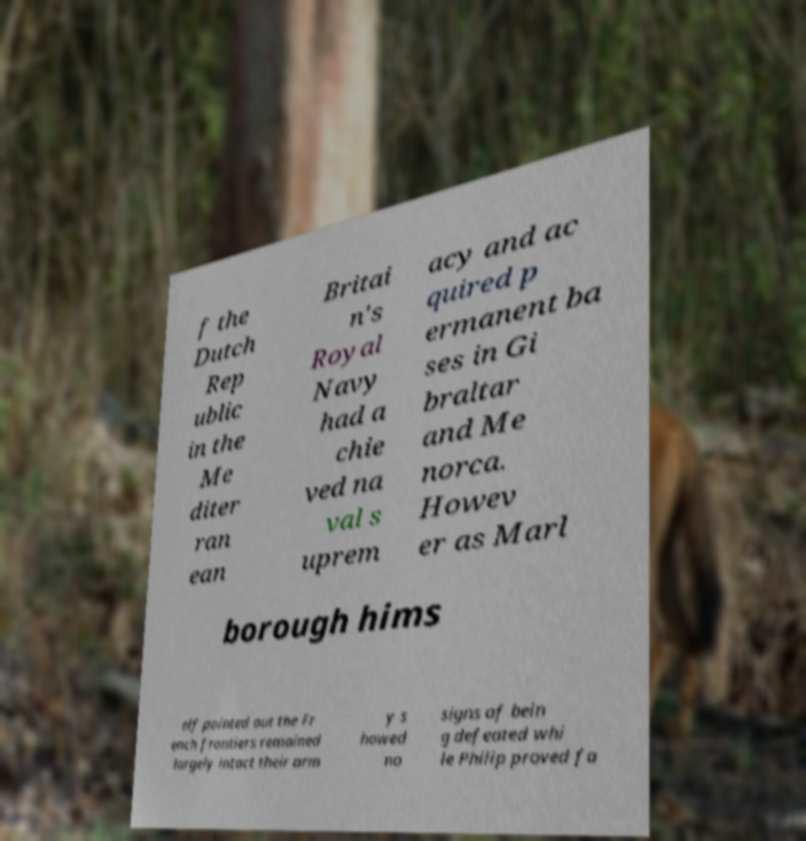There's text embedded in this image that I need extracted. Can you transcribe it verbatim? f the Dutch Rep ublic in the Me diter ran ean Britai n's Royal Navy had a chie ved na val s uprem acy and ac quired p ermanent ba ses in Gi braltar and Me norca. Howev er as Marl borough hims elf pointed out the Fr ench frontiers remained largely intact their arm y s howed no signs of bein g defeated whi le Philip proved fa 